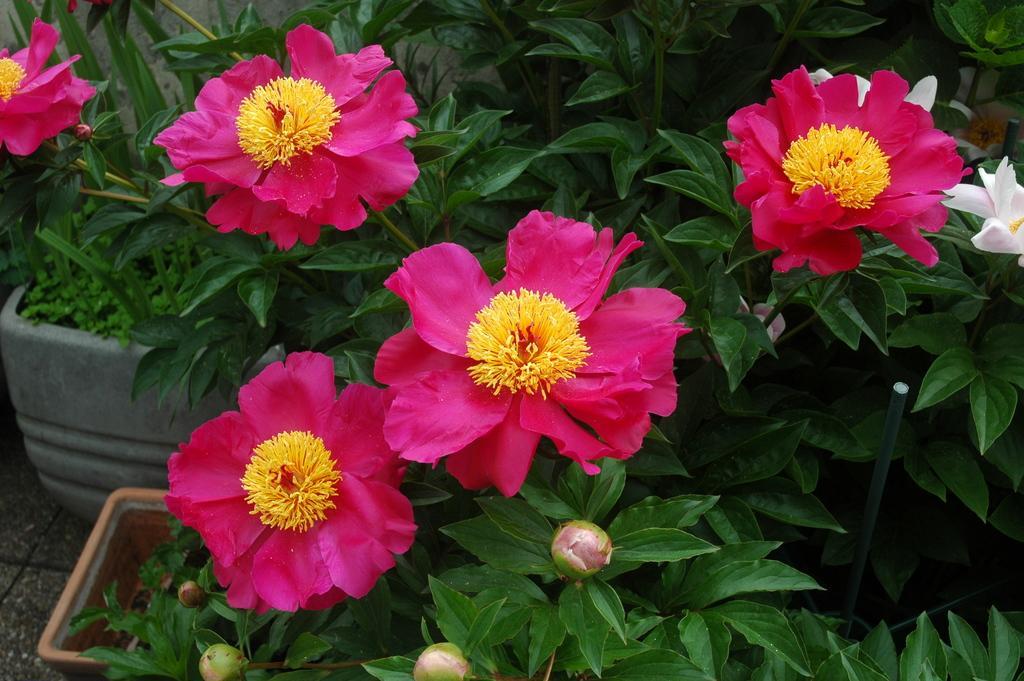Describe this image in one or two sentences. In this image we can see some potted plants with flowers and buds. 